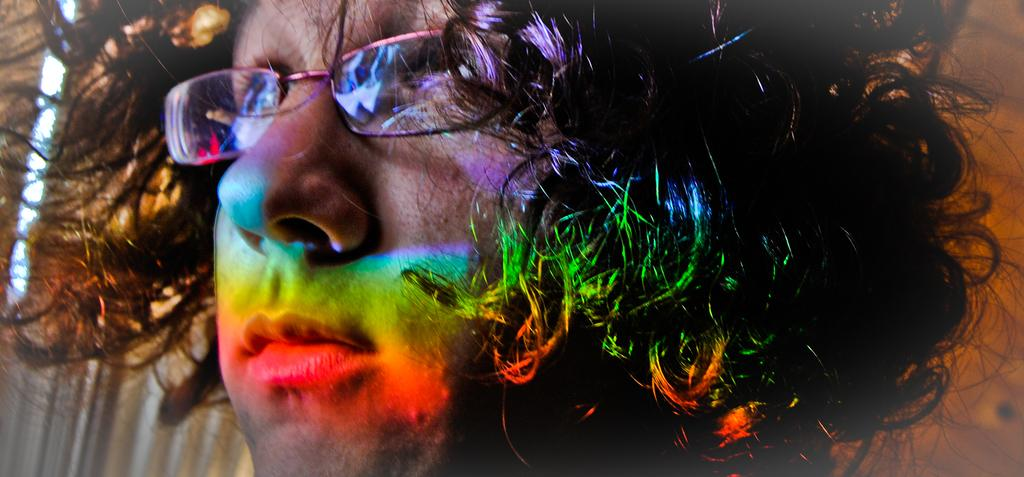What is the main subject of the image? The main subject of the image is a person's face. What accessory is the person wearing in the image? The person is wearing glasses in the image. Are there any additional features visible on the person's face? Yes, there are lights visible on the person's face. What type of stem is being used for the person's treatment in the image? There is no stem or treatment present in the image; it only features a person's face with glasses and lights. How does the zephyr affect the person's face in the image? There is no zephyr present in the image, so its effect on the person's face cannot be determined. 